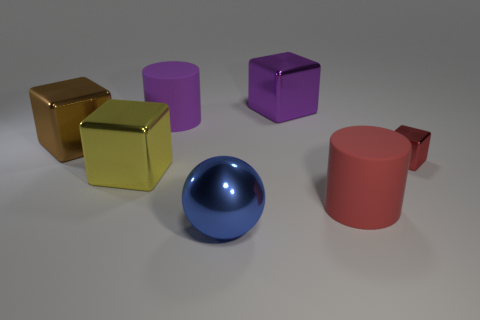There is a matte object that is the same color as the small cube; what is its size?
Provide a succinct answer. Large. Are there any cylinders of the same color as the tiny metallic object?
Ensure brevity in your answer.  Yes. What shape is the blue object that is the same material as the yellow block?
Provide a short and direct response. Sphere. What number of big things are both behind the yellow metal cube and left of the purple matte object?
Ensure brevity in your answer.  1. Are there any big purple metallic cubes in front of the yellow metal object?
Your response must be concise. No. There is a purple object to the left of the sphere; is it the same shape as the large matte object that is on the right side of the large purple rubber thing?
Keep it short and to the point. Yes. How many objects are purple metallic blocks or metal things behind the big yellow metal object?
Your answer should be compact. 3. What number of other things are there of the same shape as the large brown metal thing?
Your answer should be very brief. 3. Does the large purple object that is left of the big blue shiny object have the same material as the big blue sphere?
Ensure brevity in your answer.  No. What number of objects are brown objects or big gray cylinders?
Your answer should be compact. 1. 